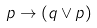Convert formula to latex. <formula><loc_0><loc_0><loc_500><loc_500>p \to ( q \lor p )</formula> 